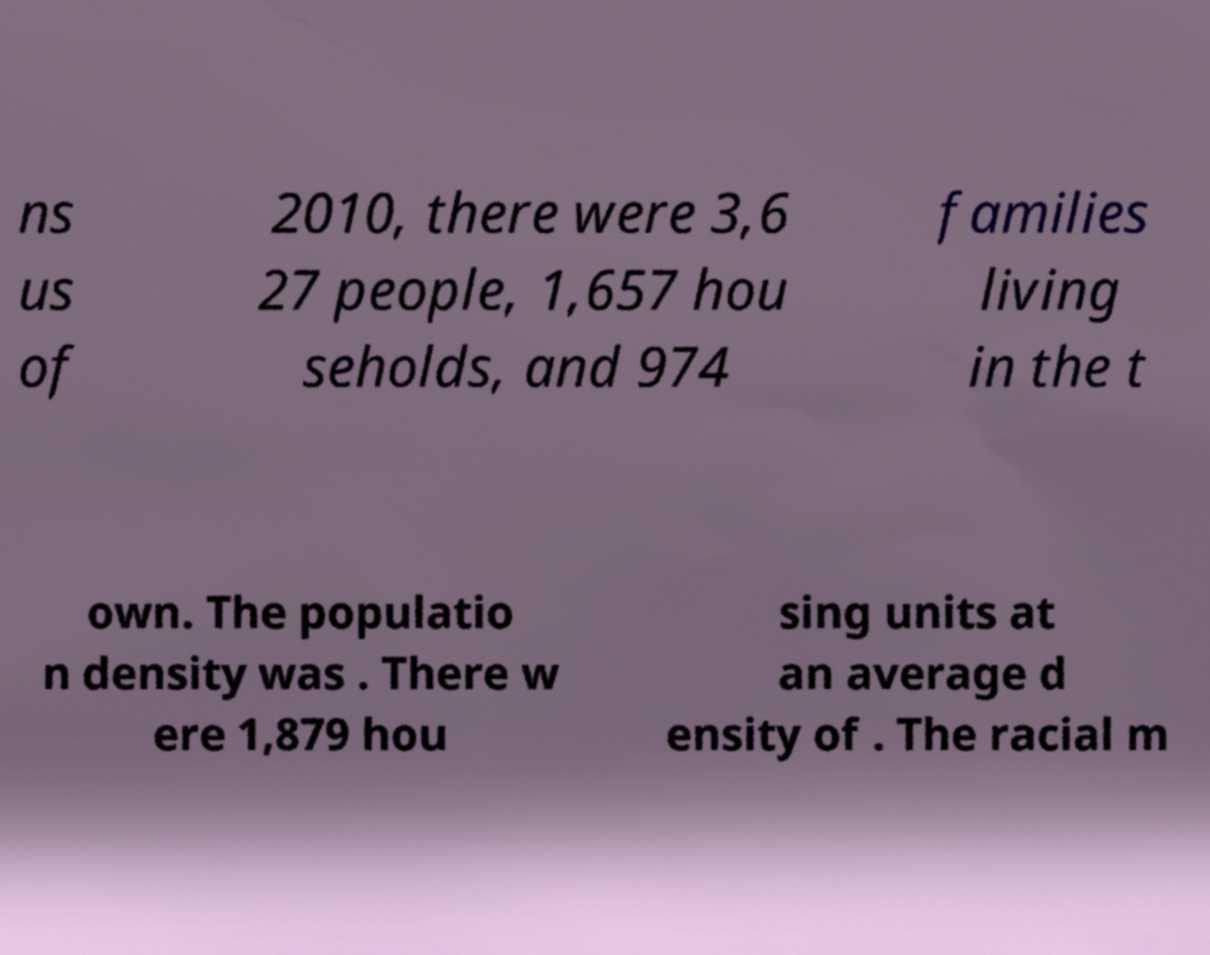For documentation purposes, I need the text within this image transcribed. Could you provide that? ns us of 2010, there were 3,6 27 people, 1,657 hou seholds, and 974 families living in the t own. The populatio n density was . There w ere 1,879 hou sing units at an average d ensity of . The racial m 